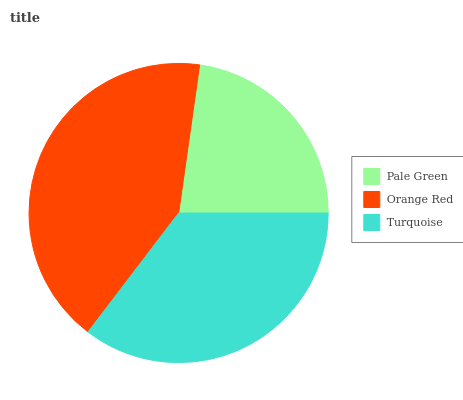Is Pale Green the minimum?
Answer yes or no. Yes. Is Orange Red the maximum?
Answer yes or no. Yes. Is Turquoise the minimum?
Answer yes or no. No. Is Turquoise the maximum?
Answer yes or no. No. Is Orange Red greater than Turquoise?
Answer yes or no. Yes. Is Turquoise less than Orange Red?
Answer yes or no. Yes. Is Turquoise greater than Orange Red?
Answer yes or no. No. Is Orange Red less than Turquoise?
Answer yes or no. No. Is Turquoise the high median?
Answer yes or no. Yes. Is Turquoise the low median?
Answer yes or no. Yes. Is Orange Red the high median?
Answer yes or no. No. Is Orange Red the low median?
Answer yes or no. No. 